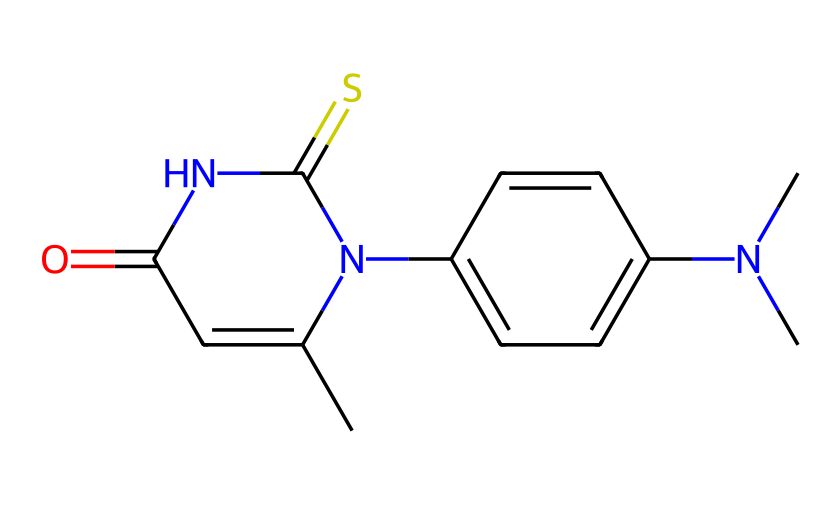what is the total number of carbon atoms in this chemical? By analyzing the SMILES representation, we can count the number of 'C' atoms, which indicates carbon. The structure shows a total of 10 'C' atoms indicating the total number of carbon atoms present.
Answer: 10 how many nitrogen atoms are present in the chemical? In the provided SMILES, we look for 'N' to determine the number of nitrogen atoms. By counting them in the structure, we find there are 3 nitrogen atoms.
Answer: 3 what is the functional group represented by the ‘=O’ in the structure? The ‘=O’ indicates the presence of a carbonyl functional group, which can be part of various chemical functionalities such as amides or ketones. Given its context here, it specifically relates to the amide functional group for hair dye chemistry.
Answer: carbonyl what type of chemical behavior might the thiourea moiety (highlighted by the 'N=C=S') contribute to hair dye effects? The thiourea group can provide nucleophilic properties that facilitate chemical reactions, which are essential for hair dye adherence and stability on hair fibers. This contributes to effective color retention and change.
Answer: nucleophilic which segment of the chemical is most likely responsible for its dyeing properties? The aromatic ring present in the structure (C2=CC=C(C=C2)) is typically responsible for coloration in dyes, as these systems can absorb specific wavelengths of light leading to vivid colors.
Answer: aromatic ring what does the presence of multiple nitrogen atoms generally indicate about the hair dye's solubility? Multiple nitrogen atoms suggest that this compound may have increased polarity, enhancing water solubility. This is advantageous for a hair dye to effectively penetrate the hair shaft during the dyeing process.
Answer: increased polarity 